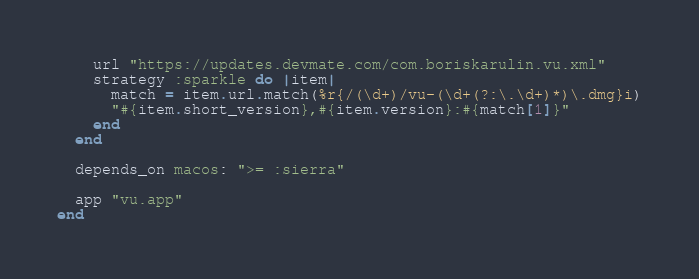Convert code to text. <code><loc_0><loc_0><loc_500><loc_500><_Ruby_>    url "https://updates.devmate.com/com.boriskarulin.vu.xml"
    strategy :sparkle do |item|
      match = item.url.match(%r{/(\d+)/vu-(\d+(?:\.\d+)*)\.dmg}i)
      "#{item.short_version},#{item.version}:#{match[1]}"
    end
  end

  depends_on macos: ">= :sierra"

  app "vu.app"
end
</code> 